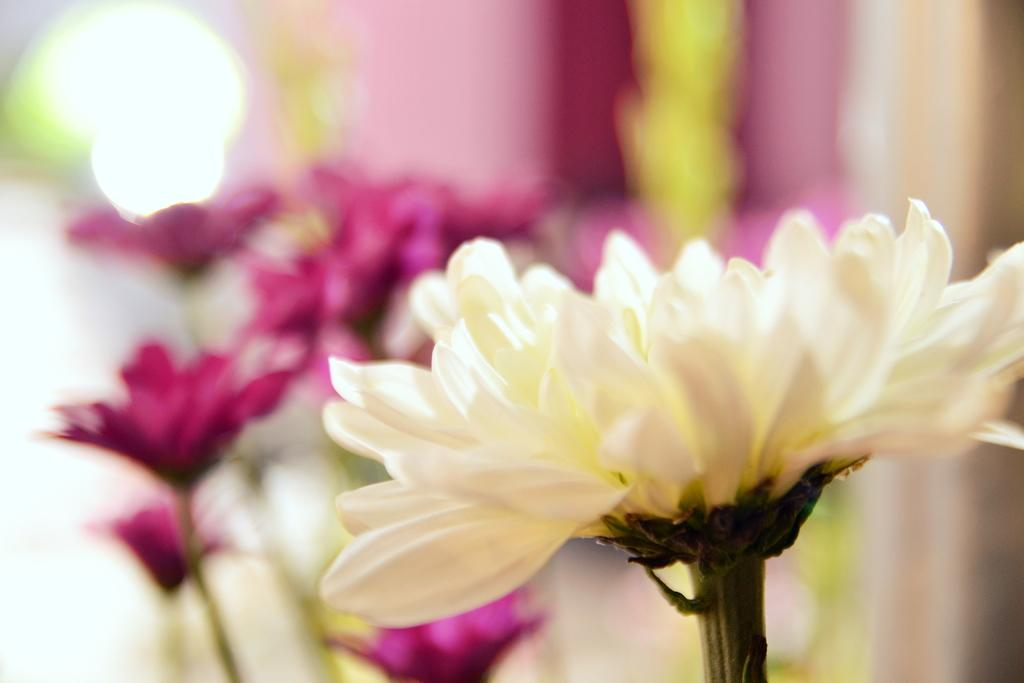What type of objects are present in the image? There are flowers in the image. Can you describe the colors of the flowers? The flowers are white and pink in color. What can be observed about the background of the image? The background of the image is blurred. What type of crime is being committed in the image? There is no crime present in the image; it features flowers with a blurred background. What advertisement is being promoted in the image? There is no advertisement present in the image; it features flowers with a blurred background. 